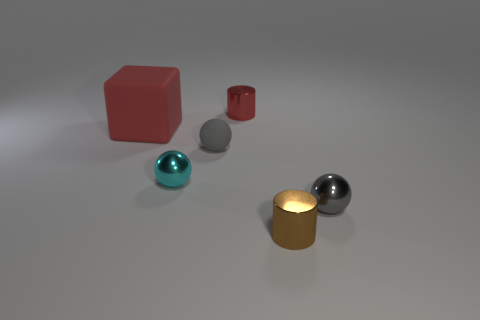Subtract 1 balls. How many balls are left? 2 Add 2 tiny gray metallic cylinders. How many objects exist? 8 Subtract all cylinders. How many objects are left? 4 Subtract 0 brown cubes. How many objects are left? 6 Subtract all cylinders. Subtract all brown shiny balls. How many objects are left? 4 Add 6 red objects. How many red objects are left? 8 Add 2 large red matte things. How many large red matte things exist? 3 